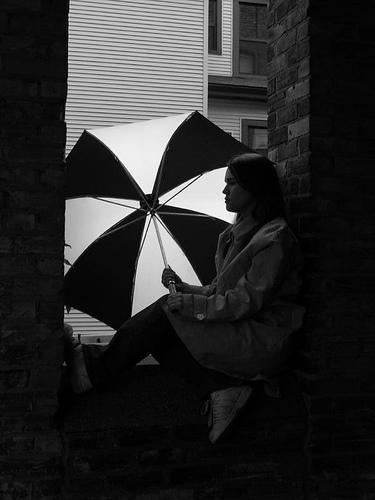How many people are visible?
Give a very brief answer. 1. 